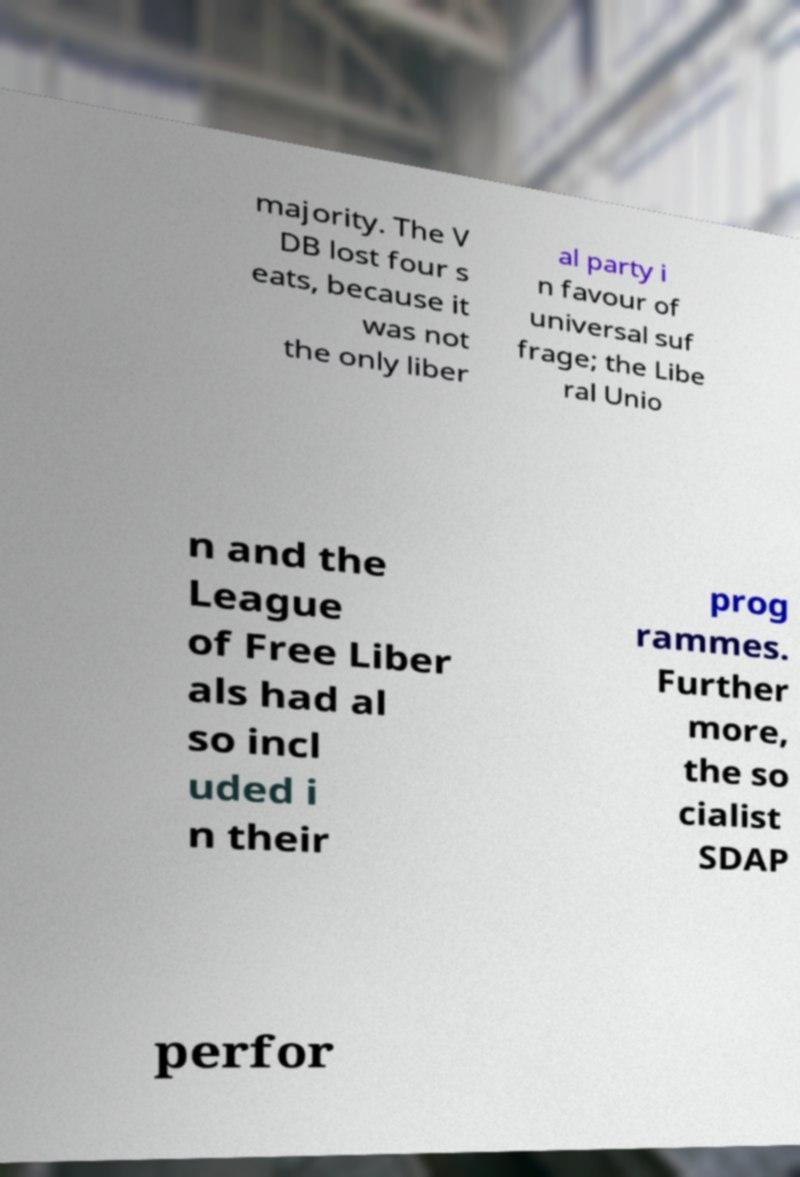Please read and relay the text visible in this image. What does it say? majority. The V DB lost four s eats, because it was not the only liber al party i n favour of universal suf frage; the Libe ral Unio n and the League of Free Liber als had al so incl uded i n their prog rammes. Further more, the so cialist SDAP perfor 